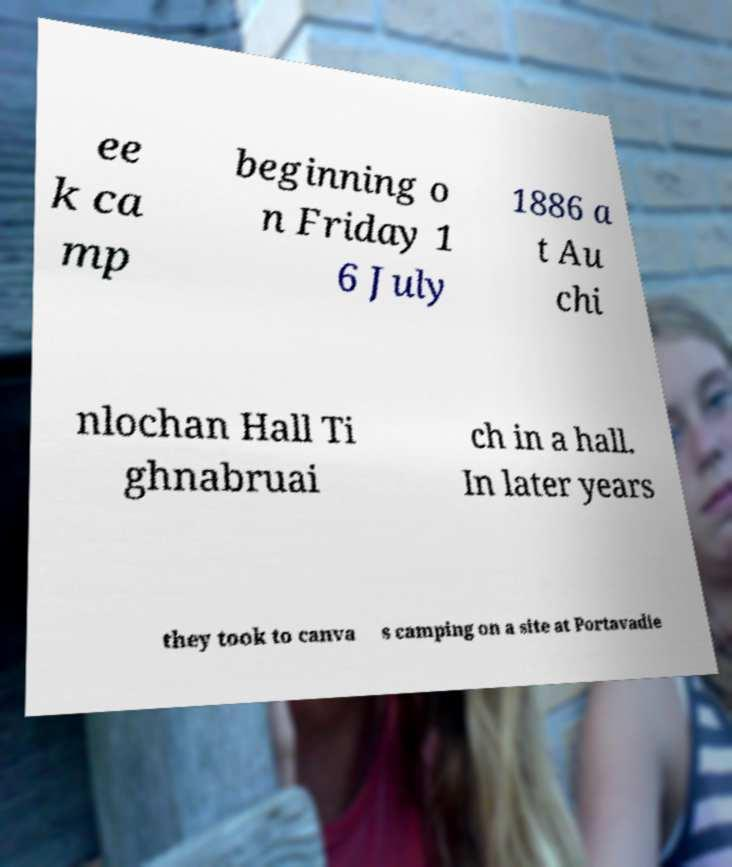Could you assist in decoding the text presented in this image and type it out clearly? ee k ca mp beginning o n Friday 1 6 July 1886 a t Au chi nlochan Hall Ti ghnabruai ch in a hall. In later years they took to canva s camping on a site at Portavadie 